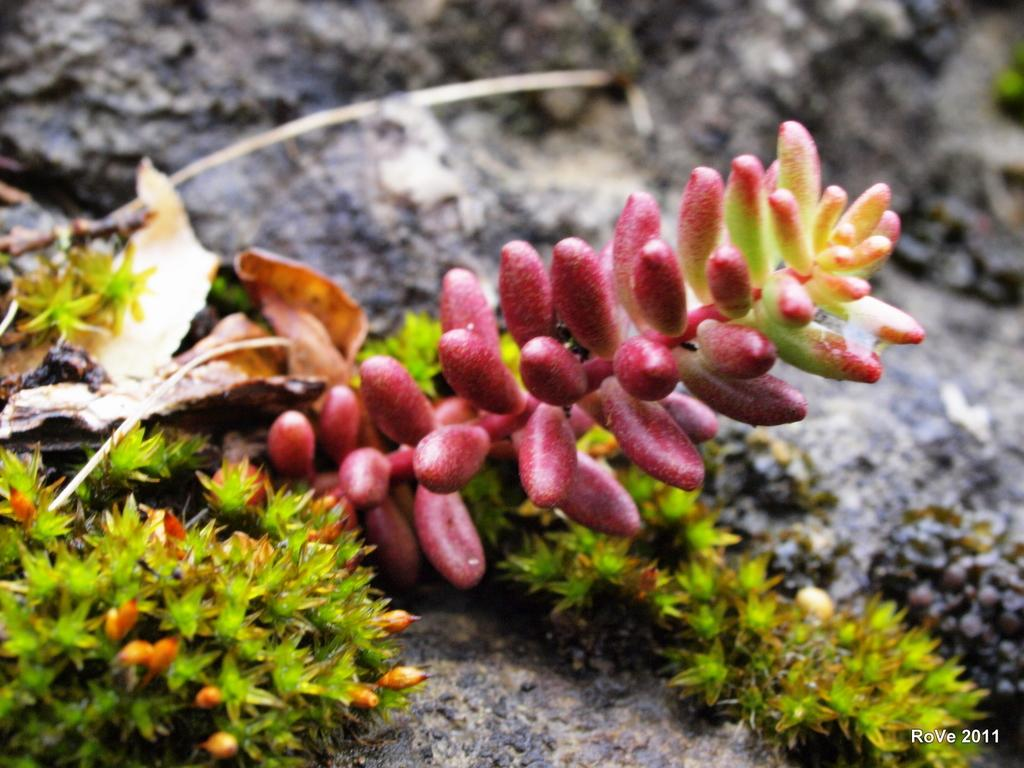What type of plants are on the left side of the image? There are plants with fruits and green leaves on the left side of the image. What can be seen on a surface in the image? There is a dry leaf on a surface in the image. How would you describe the background of the image? The background of the image is blurred. What type of education is being provided to the ants in the image? There are no ants present in the image, so no education is being provided. What material is the brick used to build the wall in the image? There is no wall or brick present in the image. 